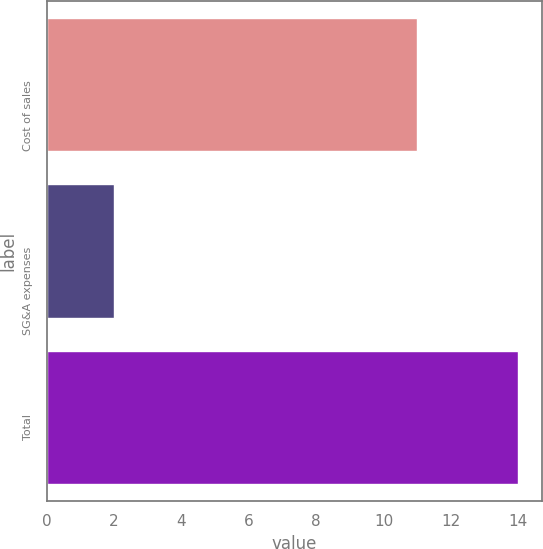<chart> <loc_0><loc_0><loc_500><loc_500><bar_chart><fcel>Cost of sales<fcel>SG&A expenses<fcel>Total<nl><fcel>11<fcel>2<fcel>14<nl></chart> 